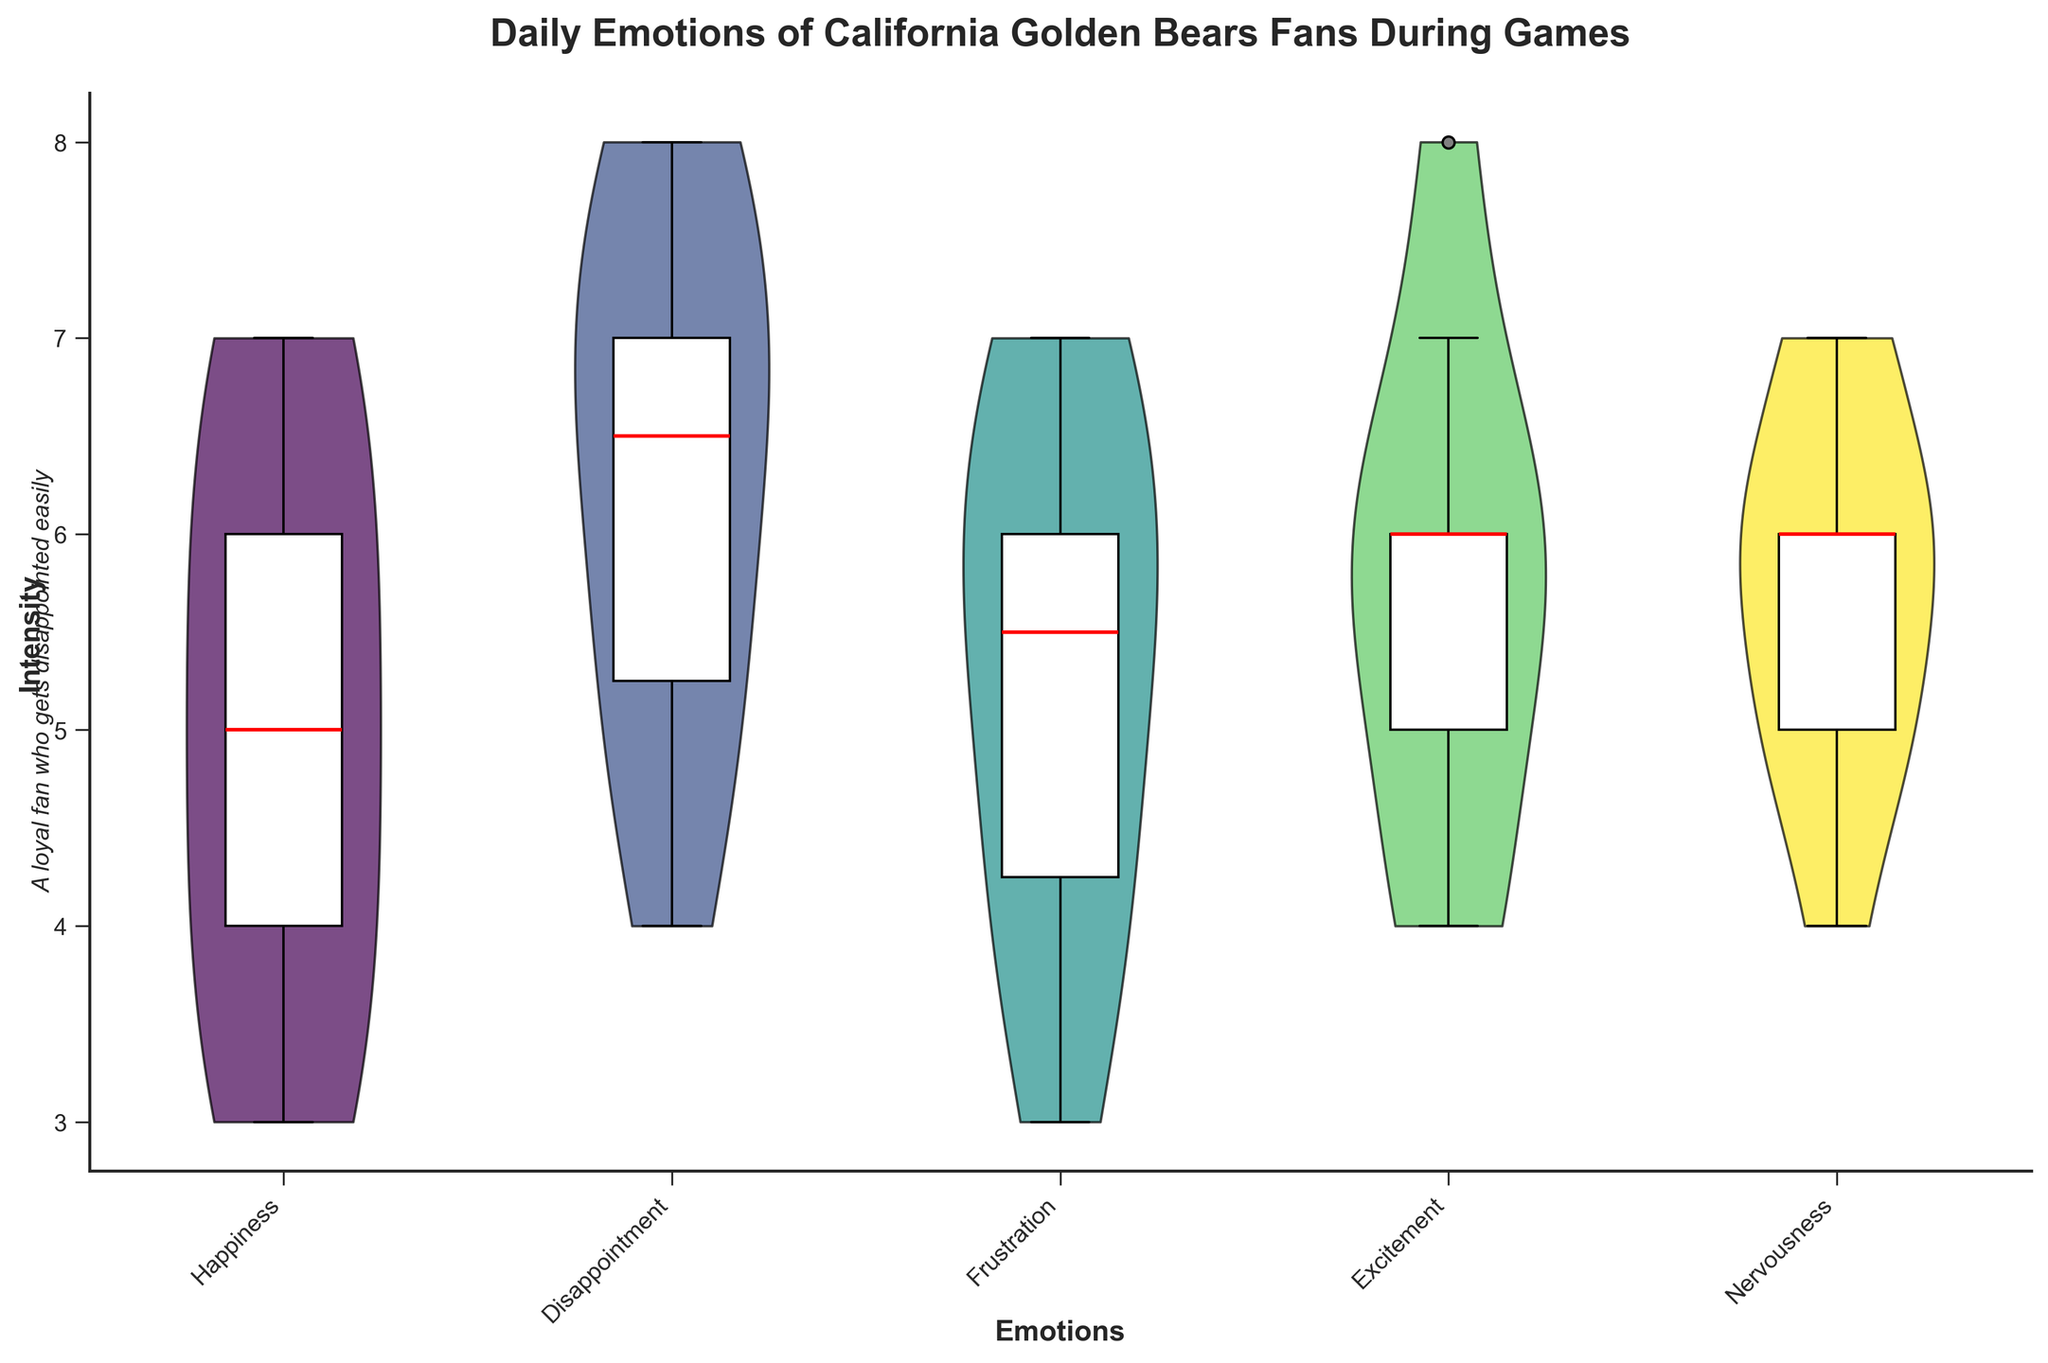Which emotion has the highest overall median intensity during the California Golden Bears games? By looking at the box plot overlays in the violin chart, the red line represents the median intensity for each emotion. Excitement has the highest median intensity as indicated by the median line in the violin plot.
Answer: Excitement What are the emotions with the lowest median intensity during the games? By observing the median lines for each emotion in the box plot overlay, Frustration and Nervousness have the lowest median intensity, both being close to 5.
Answer: Frustration and Nervousness How does the intensity distribution for disappointment compare to happiness? The violin portion of the chart shows the distribution spread. Disappointment has values mostly clustered around the higher intensities, whereas Happiness has a more varied distribution. The box plot for Disappointment also shows higher median and interquartile range compared to Happiness.
Answer: Disappointment has a higher and more clustered intensity than Happiness Which emotion shows the widest range of intensities? By examining the spread of the violin plots and the box plot whiskers, Disappointment shows the widest range, spanning from a lower intensity of around 4 to a high intensity of 8.
Answer: Disappointment What are the maximum and minimum intensities recorded for frustration? By looking at the whiskers and the outermost points of the Frustration violin plot and box plot, the maximum intensity is 7 and the minimum intensity is 3.
Answer: Maximum: 7, Minimum: 3 How is the emotion 'Nervousness' distributed across the games? The violin plot for Nervousness shows that the intensity is relatively narrow, centered around the mid values, with the box plot demonstrating a median around 6.
Answer: Centered around the mid values Is the median intensity of happiness higher or lower than excitement? By comparing the median lines in the box plots for Happiness and Excitement, it's clear that Excitement has a higher median intensity than Happiness.
Answer: Lower What can be inferred about fans' emotions based on the title and overall distribution? The title "Daily Emotions of California Golden Bears Fans During Games" coupled with the viollin charts and box plots indicates a wide array of emotional responses, with disappointment and happiness showing significant variability.
Answer: Emotions vary widely with significant disappointment and happiness Which emotion has the most consistent intensity across the games? By examining the narrowest violin plot and shortest box plot whiskers, which indicate less variability, Frustration appears to have the most consistent intensity.
Answer: Frustration What is a common characteristic between Happiness and Excitement in the plot? Both Happiness and Excitement show considerable variability as indicated by the broad spread of their respective violin plots.
Answer: Considerable variability 